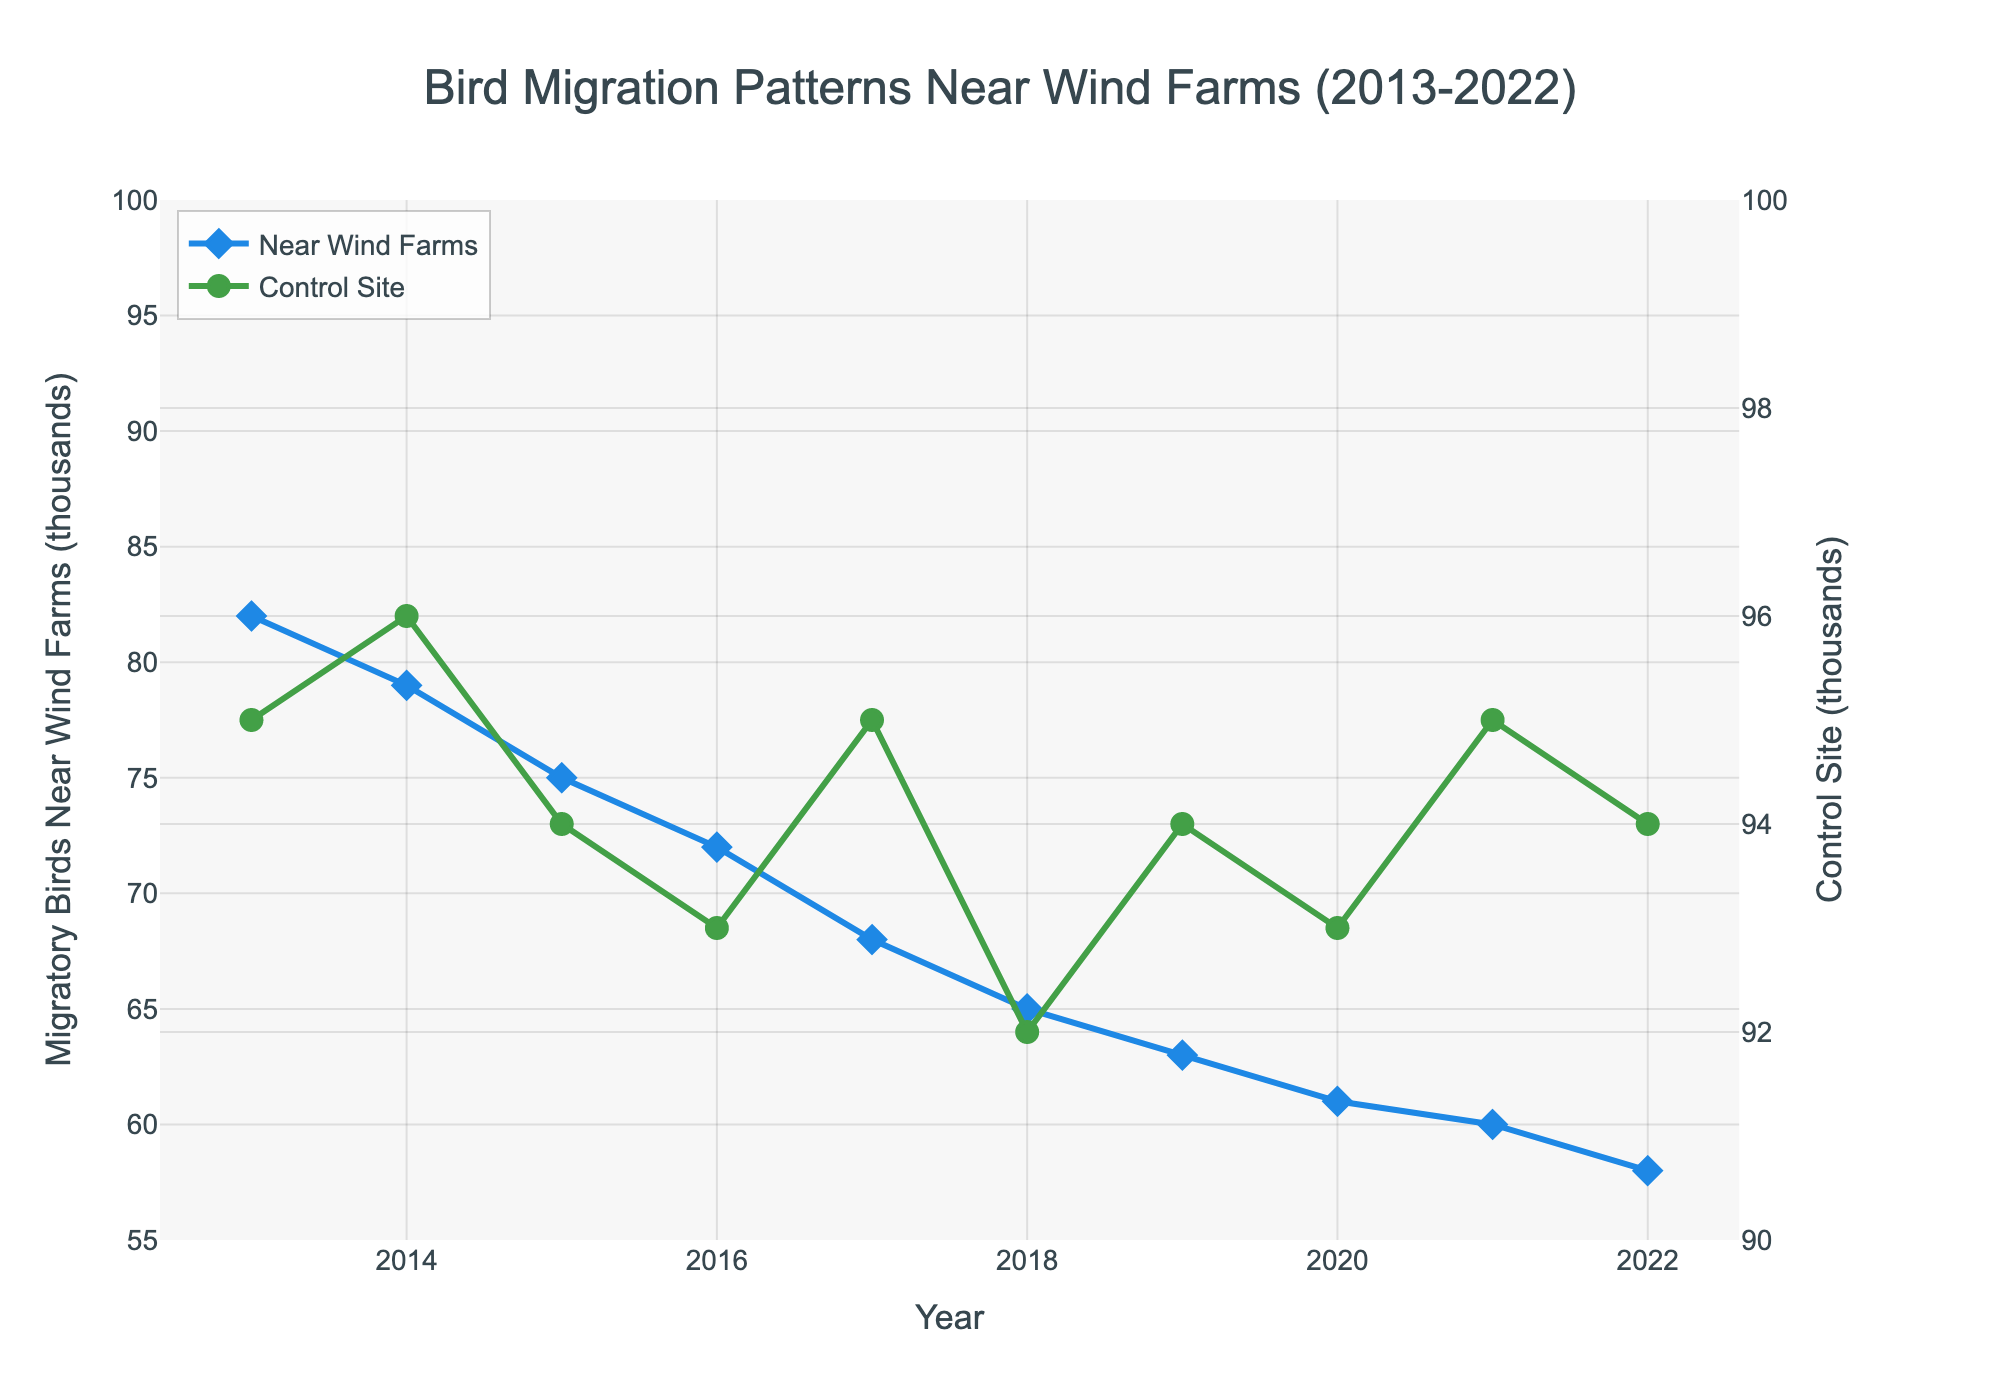What is the general trend for migratory bird populations near wind farms from 2013 to 2022? By observing the line representing the migratory birds near wind farms, it shows a downward trend from 82,000 in 2013 to 58,000 in 2022, indicating a decline.
Answer: Decline How does the general trend of migratory bird populations at the control site compare to that near wind farms? By observing the lines, the population at the control site remains relatively stable, staying around 94,000 to 96,000, while the population near wind farms shows a consistent decline.
Answer: Control site stable, wind farms decline What is the difference in the number of migratory birds at the wind farms between 2013 and 2022? The population in 2013 is 82,000, and in 2022 it is 58,000. The difference is calculated as 82,000 - 58,000, which is 24,000.
Answer: 24,000 In what year did the migratory bird population near the wind farms first fall below 70,000? By observing the slope of the line, we see that in 2017, the population was at 68,000, the first year it appears below 70,000.
Answer: 2017 Which year shows the smallest difference in bird population between the wind farm area and the control site? Differences for each year can be calculated as follows: 
2013: 95 - 82 = 13 
2014: 96 - 79 = 17 
2015: 94 - 75 = 19 
2016: 93 - 72 = 21 
2017: 95 - 68 = 27 
2018: 92 - 65 = 27 
2019: 94 - 63 = 31 
2020: 93 - 61 = 32 
2021: 95 - 60 = 35 
2022: 94 - 58 = 36 
The smallest difference is 13 in 2013.
Answer: 2013 What is the average annual decrease in migratory bird populations near the wind farms from 2013 to 2022? Calculate the total difference over the years: 82,000 (2013) - 58,000 (2022) = 24,000. The period spans 9 years (2022-2013). The average annual decrease is 24,000 / 9, which is approximately 2,666.67.
Answer: 2,666.67 Which data label corresponds to minor circular markers? The line for the control site uses circular markers, referring to the population data at the control site.
Answer: Control Site Is there any year when the migratory bird populations near wind farms and the control site were equal? By examining the lines, there is no point at which the two lines representing the populations intersect; thus, the population values have never been equal in the given timeframe.
Answer: No In what year is the largest drop observed in the migratory bird population near wind farms? By observing the slopes between consecutive points, the largest drop can be seen between 2016 and 2017, where it dropped from 72,000 to 68,000.
Answer: 2016 to 2017 